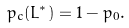Convert formula to latex. <formula><loc_0><loc_0><loc_500><loc_500>p _ { c } ( L ^ { * } ) = 1 - p _ { 0 } .</formula> 